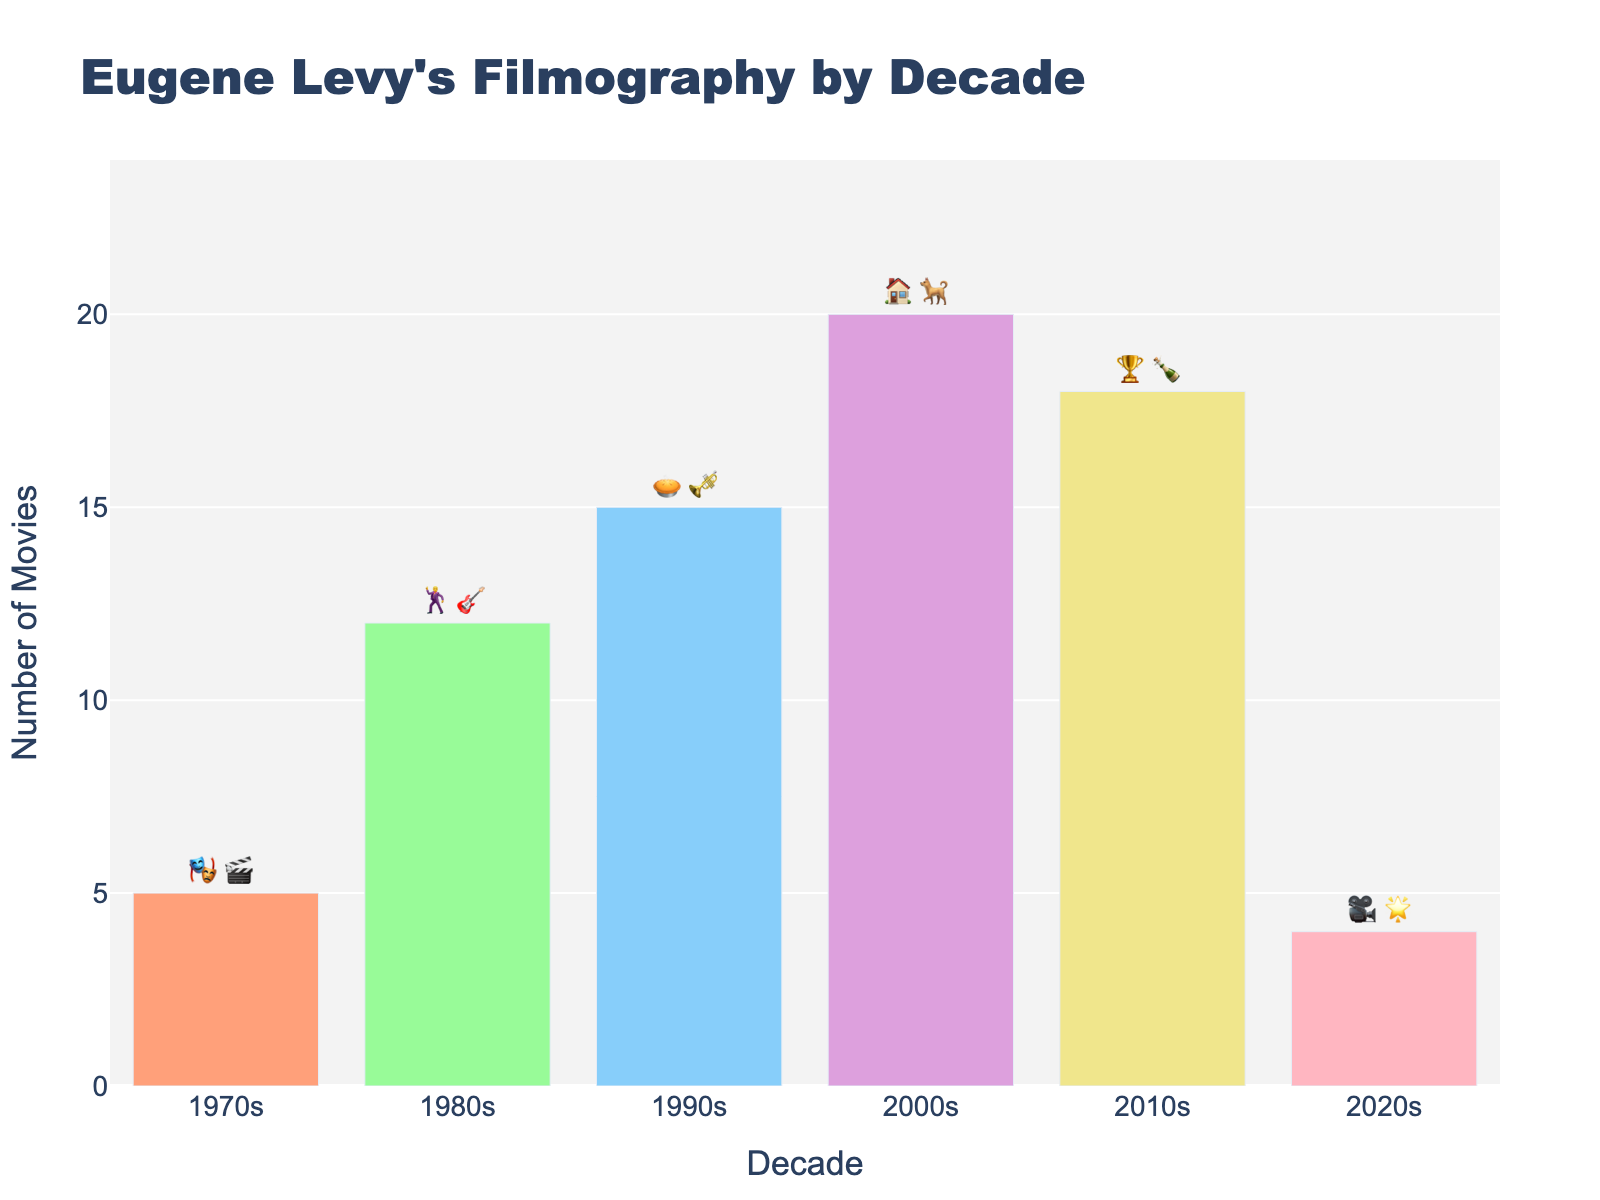Which decade has the highest number of movies? To find the decade with the highest number of movies, look at the height of the bars. The 2000s bar is the highest, indicating that this is the decade with the most movies.
Answer: 2000s What is the total number of movies from the 1990s and 2020s combined? Add the number of movies from the 1990s (15) and the 2020s (4). So, 15 + 4 = 19.
Answer: 19 How does the number of movies in the 1980s compare to the 2010s? The 1980s has 12 movies, while the 2010s has 18 movies. The difference is 18 - 12 = 6, meaning the 2010s has 6 more movies than the 1980s.
Answer: 2010s has 6 more What is the average number of movies per decade? Count the total number of movies and divide by the number of decades. The total is 5 + 12 + 15 + 20 + 18 + 4 = 74. There are 6 decades, so 74 / 6 ≈ 12.33.
Answer: 12.33 Which decade has the fewest movies? The height of the bars shows the 2020s has the shortest bar with 4 movies, indicating it has the fewest movies.
Answer: 2020s What emojis represent Eugene Levy's filmography in the 1980s? By looking at the text outside the bars, find the emoji representation for the 1980s which is indicated by "🕺🎸".
Answer: 🕺🎸 How many more movies are there in the 2000s compared to the 1970s? Subtract the number of movies in the 1970s (5) from the number of movies in the 2000s (20): 20 - 5 = 15.
Answer: 15 What's the difference in movie count between the decade with the most movies and the decade with the least movies? The decade with the most movies is the 2000s with 20 movies and the decade with the least movies is the 2020s with 4 movies. The difference is 20 - 4 = 16.
Answer: 16 Which decades have more than 10 movies? Identify the bars with counts greater than 10: the 1980s, 1990s, 2000s, and 2010s all show movie counts above 10.
Answer: 1980s, 1990s, 2000s, 2010s What's the combined movie count of the decades represented with "🏠🐕" and "🎭🎬"? The emojis "🏠🐕" represent the 2000s with 20 movies, and "🎭🎬" represent the 1970s with 5 movies. The combined count is 20 + 5 = 25.
Answer: 25 